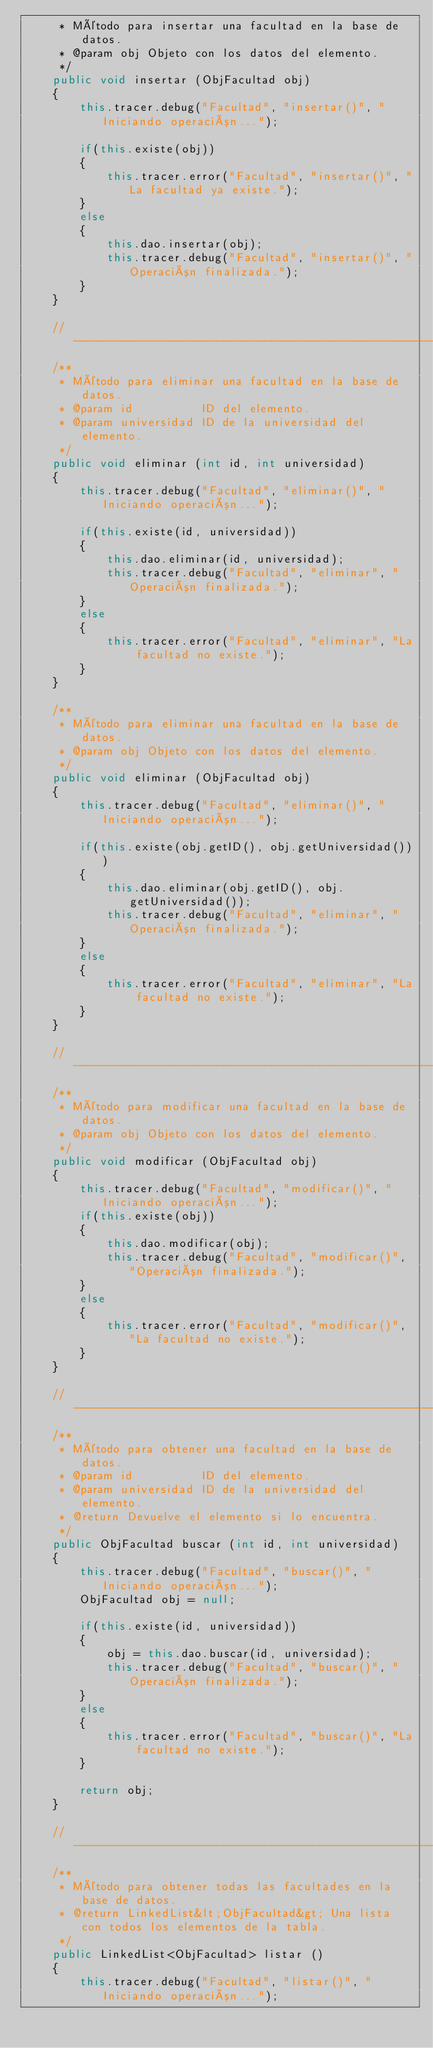Convert code to text. <code><loc_0><loc_0><loc_500><loc_500><_Java_>     * Método para insertar una facultad en la base de datos.
     * @param obj Objeto con los datos del elemento.
     */
    public void insertar (ObjFacultad obj)
    {
        this.tracer.debug("Facultad", "insertar()", "Iniciando operación...");

        if(this.existe(obj))
        {
            this.tracer.error("Facultad", "insertar()", "La facultad ya existe.");
        }
        else
        {
            this.dao.insertar(obj);
            this.tracer.debug("Facultad", "insertar()", "Operación finalizada.");
        }
    }

    //-----------------------------------------------------------------------
    /**
     * Método para eliminar una facultad en la base de datos.
     * @param id          ID del elemento.
     * @param universidad ID de la universidad del elemento.
     */
    public void eliminar (int id, int universidad)
    {
        this.tracer.debug("Facultad", "eliminar()", "Iniciando operación...");

        if(this.existe(id, universidad))
        {
            this.dao.eliminar(id, universidad);
            this.tracer.debug("Facultad", "eliminar", "Operación finalizada.");
        }
        else
        {
            this.tracer.error("Facultad", "eliminar", "La facultad no existe.");
        }
    }

    /**
     * Método para eliminar una facultad en la base de datos.
     * @param obj Objeto con los datos del elemento.
     */
    public void eliminar (ObjFacultad obj)
    {
        this.tracer.debug("Facultad", "eliminar()", "Iniciando operación...");

        if(this.existe(obj.getID(), obj.getUniversidad()))
        {
            this.dao.eliminar(obj.getID(), obj.getUniversidad());
            this.tracer.debug("Facultad", "eliminar", "Operación finalizada.");
        }
        else
        {
            this.tracer.error("Facultad", "eliminar", "La facultad no existe.");
        }
    }

    //-----------------------------------------------------------------------
    /**
     * Método para modificar una facultad en la base de datos.
     * @param obj Objeto con los datos del elemento.
     */
    public void modificar (ObjFacultad obj)
    {
        this.tracer.debug("Facultad", "modificar()", "Iniciando operación...");
        if(this.existe(obj))
        {
            this.dao.modificar(obj);
            this.tracer.debug("Facultad", "modificar()", "Operación finalizada.");
        }
        else
        {
            this.tracer.error("Facultad", "modificar()", "La facultad no existe.");
        }
    }

    //-----------------------------------------------------------------------
    /**
     * Método para obtener una facultad en la base de datos.
     * @param id          ID del elemento.
     * @param universidad ID de la universidad del elemento.
     * @return Devuelve el elemento si lo encuentra.
     */
    public ObjFacultad buscar (int id, int universidad)
    {
        this.tracer.debug("Facultad", "buscar()", "Iniciando operación...");
        ObjFacultad obj = null;

        if(this.existe(id, universidad))
        {
            obj = this.dao.buscar(id, universidad);
            this.tracer.debug("Facultad", "buscar()", "Operación finalizada.");
        }
        else
        {
            this.tracer.error("Facultad", "buscar()", "La facultad no existe.");
        }

        return obj;
    }

    //-----------------------------------------------------------------------
    /**
     * Método para obtener todas las facultades en la base de datos.
     * @return LinkedList&lt;ObjFacultad&gt; Una lista con todos los elementos de la tabla.
     */
    public LinkedList<ObjFacultad> listar ()
    {
        this.tracer.debug("Facultad", "listar()", "Iniciando operación...");</code> 